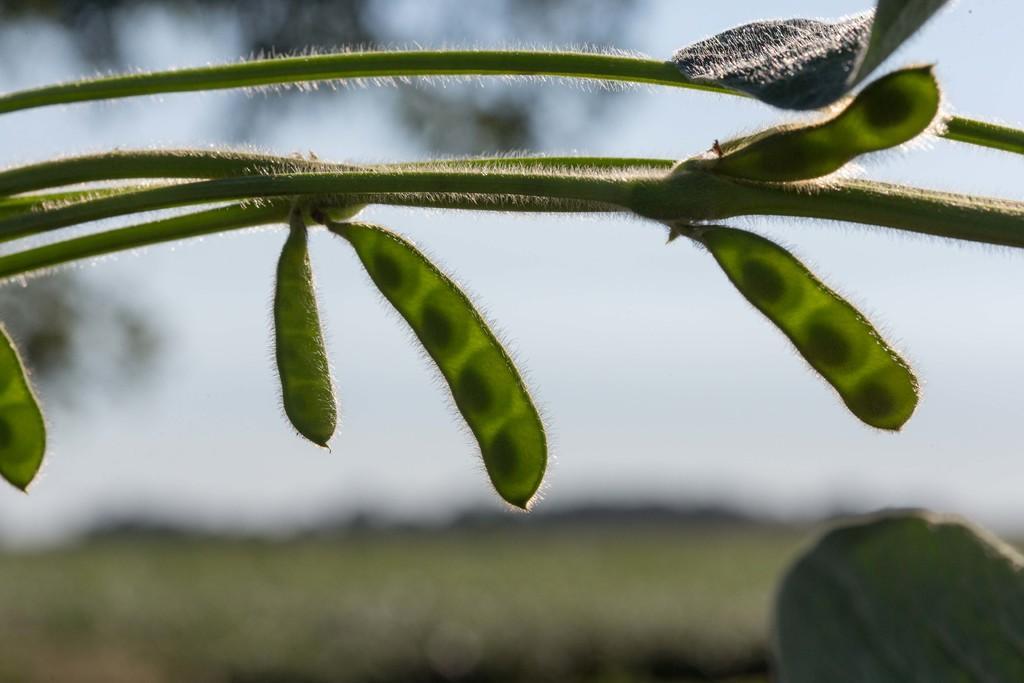Describe this image in one or two sentences. In this image there is plant and the background is blurry. 